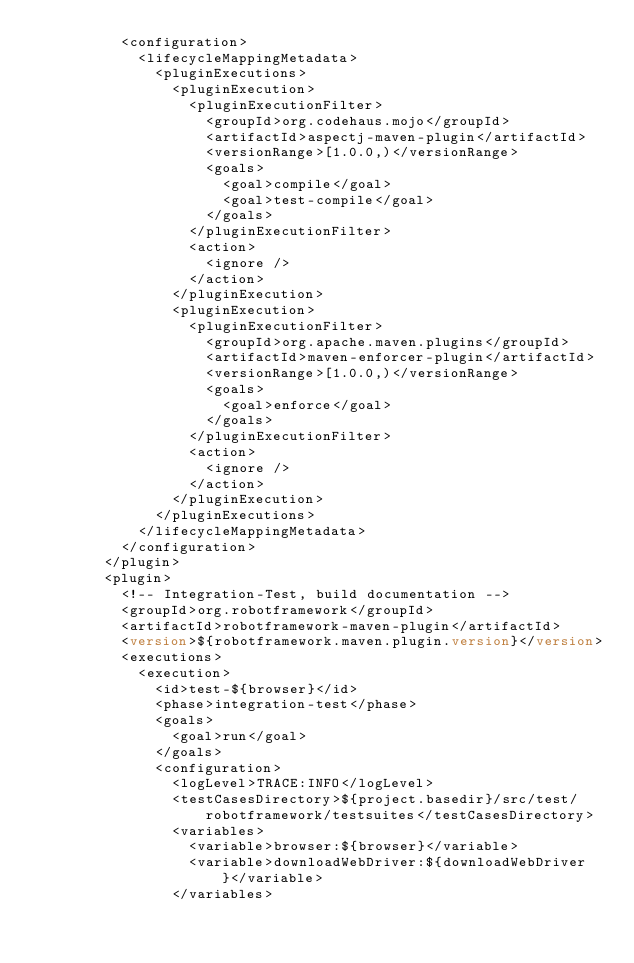Convert code to text. <code><loc_0><loc_0><loc_500><loc_500><_XML_>					<configuration>
						<lifecycleMappingMetadata>
							<pluginExecutions>
								<pluginExecution>
									<pluginExecutionFilter>
										<groupId>org.codehaus.mojo</groupId>
										<artifactId>aspectj-maven-plugin</artifactId>
										<versionRange>[1.0.0,)</versionRange>
										<goals>
											<goal>compile</goal>
											<goal>test-compile</goal>
										</goals>
									</pluginExecutionFilter>
									<action>
										<ignore />
									</action>
								</pluginExecution>
								<pluginExecution>
									<pluginExecutionFilter>
										<groupId>org.apache.maven.plugins</groupId>
										<artifactId>maven-enforcer-plugin</artifactId>
										<versionRange>[1.0.0,)</versionRange>
										<goals>
											<goal>enforce</goal>
										</goals>
									</pluginExecutionFilter>
									<action>
										<ignore />
									</action>
								</pluginExecution>
							</pluginExecutions>
						</lifecycleMappingMetadata>
					</configuration>
				</plugin>
				<plugin>
					<!-- Integration-Test, build documentation -->
					<groupId>org.robotframework</groupId>
					<artifactId>robotframework-maven-plugin</artifactId>
					<version>${robotframework.maven.plugin.version}</version>
					<executions>
						<execution>
							<id>test-${browser}</id>
							<phase>integration-test</phase>
							<goals>
								<goal>run</goal>
							</goals>
							<configuration>
								<logLevel>TRACE:INFO</logLevel>
								<testCasesDirectory>${project.basedir}/src/test/robotframework/testsuites</testCasesDirectory>
								<variables>
									<variable>browser:${browser}</variable>
									<variable>downloadWebDriver:${downloadWebDriver}</variable>
								</variables></code> 